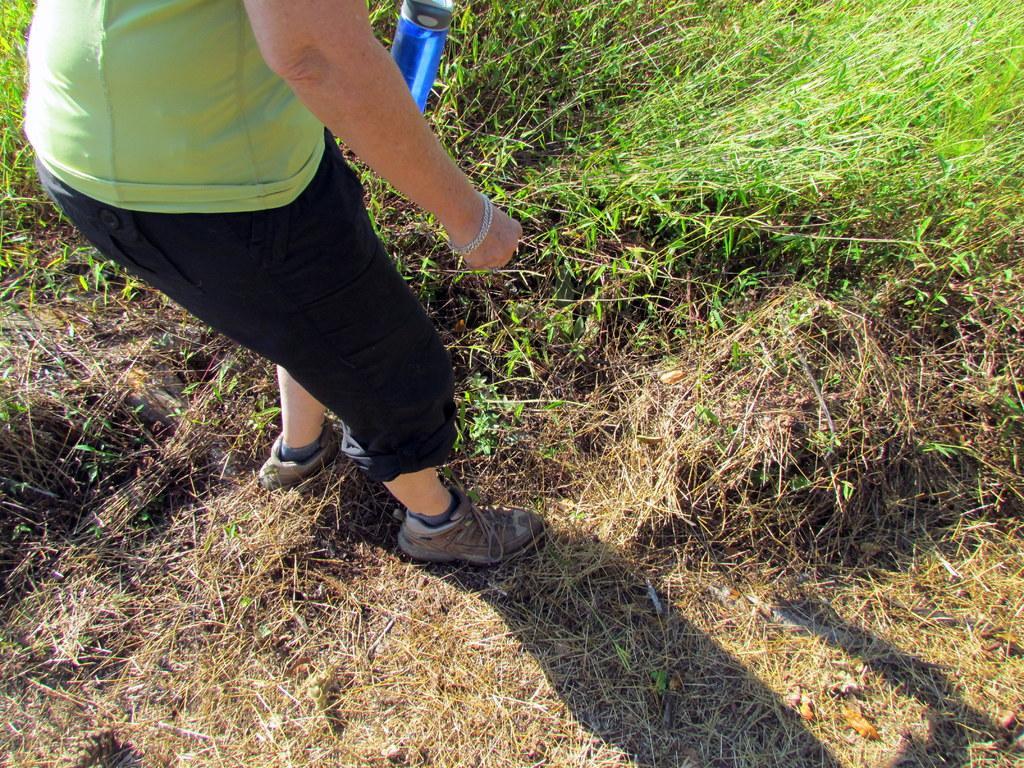How would you summarize this image in a sentence or two? In the picture there is some green grass and dry grass and a person is standing on the dry grass and holding a bottle with the hand, the shadow of the person is reflecting on the ground. 